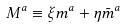Convert formula to latex. <formula><loc_0><loc_0><loc_500><loc_500>M ^ { a } \equiv \xi m ^ { a } + \eta \bar { m } ^ { a }</formula> 